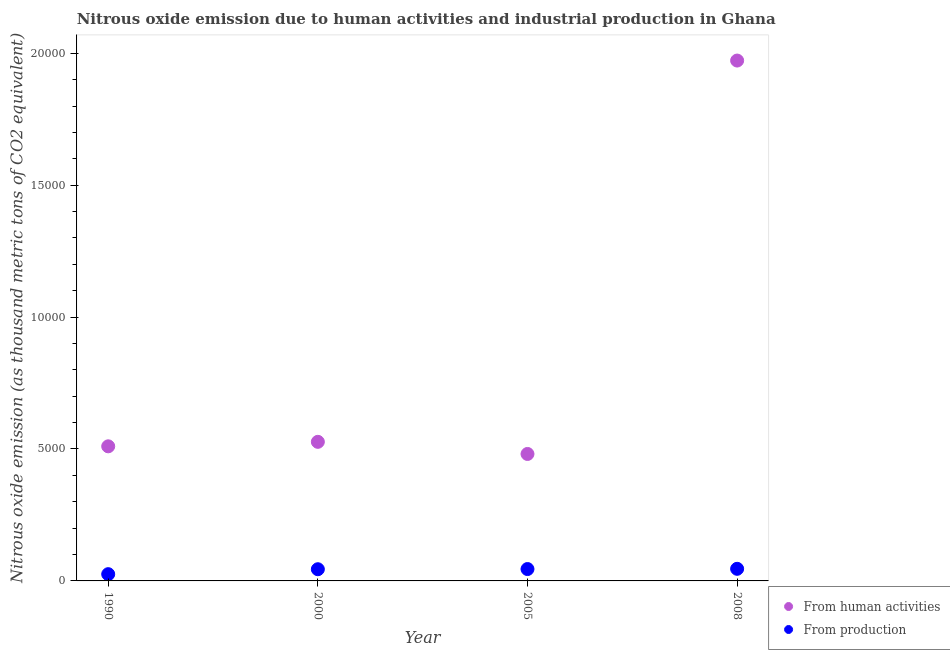What is the amount of emissions generated from industries in 2000?
Ensure brevity in your answer.  443.1. Across all years, what is the maximum amount of emissions generated from industries?
Ensure brevity in your answer.  458.8. Across all years, what is the minimum amount of emissions from human activities?
Keep it short and to the point. 4812. What is the total amount of emissions generated from industries in the graph?
Provide a succinct answer. 1607.8. What is the difference between the amount of emissions generated from industries in 1990 and that in 2005?
Your response must be concise. -193.9. What is the difference between the amount of emissions generated from industries in 1990 and the amount of emissions from human activities in 2005?
Provide a short and direct response. -4556. What is the average amount of emissions generated from industries per year?
Give a very brief answer. 401.95. In the year 2000, what is the difference between the amount of emissions generated from industries and amount of emissions from human activities?
Your answer should be very brief. -4828.3. What is the ratio of the amount of emissions generated from industries in 1990 to that in 2008?
Your answer should be compact. 0.56. Is the amount of emissions generated from industries in 2000 less than that in 2008?
Your answer should be compact. Yes. Is the difference between the amount of emissions from human activities in 1990 and 2000 greater than the difference between the amount of emissions generated from industries in 1990 and 2000?
Offer a terse response. Yes. What is the difference between the highest and the second highest amount of emissions generated from industries?
Provide a short and direct response. 8.9. What is the difference between the highest and the lowest amount of emissions generated from industries?
Keep it short and to the point. 202.8. In how many years, is the amount of emissions from human activities greater than the average amount of emissions from human activities taken over all years?
Your answer should be compact. 1. Does the amount of emissions from human activities monotonically increase over the years?
Ensure brevity in your answer.  No. Is the amount of emissions generated from industries strictly greater than the amount of emissions from human activities over the years?
Ensure brevity in your answer.  No. Is the amount of emissions from human activities strictly less than the amount of emissions generated from industries over the years?
Make the answer very short. No. How many dotlines are there?
Your response must be concise. 2. What is the difference between two consecutive major ticks on the Y-axis?
Make the answer very short. 5000. Are the values on the major ticks of Y-axis written in scientific E-notation?
Offer a very short reply. No. Where does the legend appear in the graph?
Your answer should be very brief. Bottom right. How many legend labels are there?
Provide a short and direct response. 2. What is the title of the graph?
Your answer should be compact. Nitrous oxide emission due to human activities and industrial production in Ghana. What is the label or title of the X-axis?
Provide a succinct answer. Year. What is the label or title of the Y-axis?
Your response must be concise. Nitrous oxide emission (as thousand metric tons of CO2 equivalent). What is the Nitrous oxide emission (as thousand metric tons of CO2 equivalent) in From human activities in 1990?
Offer a terse response. 5101.4. What is the Nitrous oxide emission (as thousand metric tons of CO2 equivalent) of From production in 1990?
Offer a terse response. 256. What is the Nitrous oxide emission (as thousand metric tons of CO2 equivalent) of From human activities in 2000?
Provide a succinct answer. 5271.4. What is the Nitrous oxide emission (as thousand metric tons of CO2 equivalent) of From production in 2000?
Your answer should be very brief. 443.1. What is the Nitrous oxide emission (as thousand metric tons of CO2 equivalent) in From human activities in 2005?
Your answer should be compact. 4812. What is the Nitrous oxide emission (as thousand metric tons of CO2 equivalent) in From production in 2005?
Keep it short and to the point. 449.9. What is the Nitrous oxide emission (as thousand metric tons of CO2 equivalent) in From human activities in 2008?
Offer a terse response. 1.97e+04. What is the Nitrous oxide emission (as thousand metric tons of CO2 equivalent) of From production in 2008?
Make the answer very short. 458.8. Across all years, what is the maximum Nitrous oxide emission (as thousand metric tons of CO2 equivalent) in From human activities?
Your answer should be very brief. 1.97e+04. Across all years, what is the maximum Nitrous oxide emission (as thousand metric tons of CO2 equivalent) of From production?
Give a very brief answer. 458.8. Across all years, what is the minimum Nitrous oxide emission (as thousand metric tons of CO2 equivalent) of From human activities?
Give a very brief answer. 4812. Across all years, what is the minimum Nitrous oxide emission (as thousand metric tons of CO2 equivalent) in From production?
Provide a short and direct response. 256. What is the total Nitrous oxide emission (as thousand metric tons of CO2 equivalent) of From human activities in the graph?
Your answer should be compact. 3.49e+04. What is the total Nitrous oxide emission (as thousand metric tons of CO2 equivalent) of From production in the graph?
Your answer should be compact. 1607.8. What is the difference between the Nitrous oxide emission (as thousand metric tons of CO2 equivalent) in From human activities in 1990 and that in 2000?
Your answer should be very brief. -170. What is the difference between the Nitrous oxide emission (as thousand metric tons of CO2 equivalent) in From production in 1990 and that in 2000?
Your response must be concise. -187.1. What is the difference between the Nitrous oxide emission (as thousand metric tons of CO2 equivalent) of From human activities in 1990 and that in 2005?
Give a very brief answer. 289.4. What is the difference between the Nitrous oxide emission (as thousand metric tons of CO2 equivalent) of From production in 1990 and that in 2005?
Keep it short and to the point. -193.9. What is the difference between the Nitrous oxide emission (as thousand metric tons of CO2 equivalent) in From human activities in 1990 and that in 2008?
Your response must be concise. -1.46e+04. What is the difference between the Nitrous oxide emission (as thousand metric tons of CO2 equivalent) in From production in 1990 and that in 2008?
Your answer should be compact. -202.8. What is the difference between the Nitrous oxide emission (as thousand metric tons of CO2 equivalent) in From human activities in 2000 and that in 2005?
Keep it short and to the point. 459.4. What is the difference between the Nitrous oxide emission (as thousand metric tons of CO2 equivalent) in From human activities in 2000 and that in 2008?
Your response must be concise. -1.45e+04. What is the difference between the Nitrous oxide emission (as thousand metric tons of CO2 equivalent) in From production in 2000 and that in 2008?
Offer a terse response. -15.7. What is the difference between the Nitrous oxide emission (as thousand metric tons of CO2 equivalent) in From human activities in 2005 and that in 2008?
Make the answer very short. -1.49e+04. What is the difference between the Nitrous oxide emission (as thousand metric tons of CO2 equivalent) of From human activities in 1990 and the Nitrous oxide emission (as thousand metric tons of CO2 equivalent) of From production in 2000?
Ensure brevity in your answer.  4658.3. What is the difference between the Nitrous oxide emission (as thousand metric tons of CO2 equivalent) in From human activities in 1990 and the Nitrous oxide emission (as thousand metric tons of CO2 equivalent) in From production in 2005?
Make the answer very short. 4651.5. What is the difference between the Nitrous oxide emission (as thousand metric tons of CO2 equivalent) in From human activities in 1990 and the Nitrous oxide emission (as thousand metric tons of CO2 equivalent) in From production in 2008?
Ensure brevity in your answer.  4642.6. What is the difference between the Nitrous oxide emission (as thousand metric tons of CO2 equivalent) of From human activities in 2000 and the Nitrous oxide emission (as thousand metric tons of CO2 equivalent) of From production in 2005?
Provide a short and direct response. 4821.5. What is the difference between the Nitrous oxide emission (as thousand metric tons of CO2 equivalent) in From human activities in 2000 and the Nitrous oxide emission (as thousand metric tons of CO2 equivalent) in From production in 2008?
Ensure brevity in your answer.  4812.6. What is the difference between the Nitrous oxide emission (as thousand metric tons of CO2 equivalent) of From human activities in 2005 and the Nitrous oxide emission (as thousand metric tons of CO2 equivalent) of From production in 2008?
Ensure brevity in your answer.  4353.2. What is the average Nitrous oxide emission (as thousand metric tons of CO2 equivalent) in From human activities per year?
Your answer should be very brief. 8726.83. What is the average Nitrous oxide emission (as thousand metric tons of CO2 equivalent) in From production per year?
Make the answer very short. 401.95. In the year 1990, what is the difference between the Nitrous oxide emission (as thousand metric tons of CO2 equivalent) of From human activities and Nitrous oxide emission (as thousand metric tons of CO2 equivalent) of From production?
Ensure brevity in your answer.  4845.4. In the year 2000, what is the difference between the Nitrous oxide emission (as thousand metric tons of CO2 equivalent) in From human activities and Nitrous oxide emission (as thousand metric tons of CO2 equivalent) in From production?
Your response must be concise. 4828.3. In the year 2005, what is the difference between the Nitrous oxide emission (as thousand metric tons of CO2 equivalent) of From human activities and Nitrous oxide emission (as thousand metric tons of CO2 equivalent) of From production?
Offer a terse response. 4362.1. In the year 2008, what is the difference between the Nitrous oxide emission (as thousand metric tons of CO2 equivalent) of From human activities and Nitrous oxide emission (as thousand metric tons of CO2 equivalent) of From production?
Keep it short and to the point. 1.93e+04. What is the ratio of the Nitrous oxide emission (as thousand metric tons of CO2 equivalent) of From human activities in 1990 to that in 2000?
Make the answer very short. 0.97. What is the ratio of the Nitrous oxide emission (as thousand metric tons of CO2 equivalent) of From production in 1990 to that in 2000?
Provide a short and direct response. 0.58. What is the ratio of the Nitrous oxide emission (as thousand metric tons of CO2 equivalent) in From human activities in 1990 to that in 2005?
Make the answer very short. 1.06. What is the ratio of the Nitrous oxide emission (as thousand metric tons of CO2 equivalent) of From production in 1990 to that in 2005?
Make the answer very short. 0.57. What is the ratio of the Nitrous oxide emission (as thousand metric tons of CO2 equivalent) of From human activities in 1990 to that in 2008?
Your answer should be compact. 0.26. What is the ratio of the Nitrous oxide emission (as thousand metric tons of CO2 equivalent) in From production in 1990 to that in 2008?
Provide a short and direct response. 0.56. What is the ratio of the Nitrous oxide emission (as thousand metric tons of CO2 equivalent) of From human activities in 2000 to that in 2005?
Keep it short and to the point. 1.1. What is the ratio of the Nitrous oxide emission (as thousand metric tons of CO2 equivalent) in From production in 2000 to that in 2005?
Offer a terse response. 0.98. What is the ratio of the Nitrous oxide emission (as thousand metric tons of CO2 equivalent) in From human activities in 2000 to that in 2008?
Provide a short and direct response. 0.27. What is the ratio of the Nitrous oxide emission (as thousand metric tons of CO2 equivalent) of From production in 2000 to that in 2008?
Your answer should be very brief. 0.97. What is the ratio of the Nitrous oxide emission (as thousand metric tons of CO2 equivalent) of From human activities in 2005 to that in 2008?
Offer a very short reply. 0.24. What is the ratio of the Nitrous oxide emission (as thousand metric tons of CO2 equivalent) of From production in 2005 to that in 2008?
Make the answer very short. 0.98. What is the difference between the highest and the second highest Nitrous oxide emission (as thousand metric tons of CO2 equivalent) in From human activities?
Your response must be concise. 1.45e+04. What is the difference between the highest and the second highest Nitrous oxide emission (as thousand metric tons of CO2 equivalent) in From production?
Your response must be concise. 8.9. What is the difference between the highest and the lowest Nitrous oxide emission (as thousand metric tons of CO2 equivalent) in From human activities?
Offer a terse response. 1.49e+04. What is the difference between the highest and the lowest Nitrous oxide emission (as thousand metric tons of CO2 equivalent) in From production?
Offer a terse response. 202.8. 